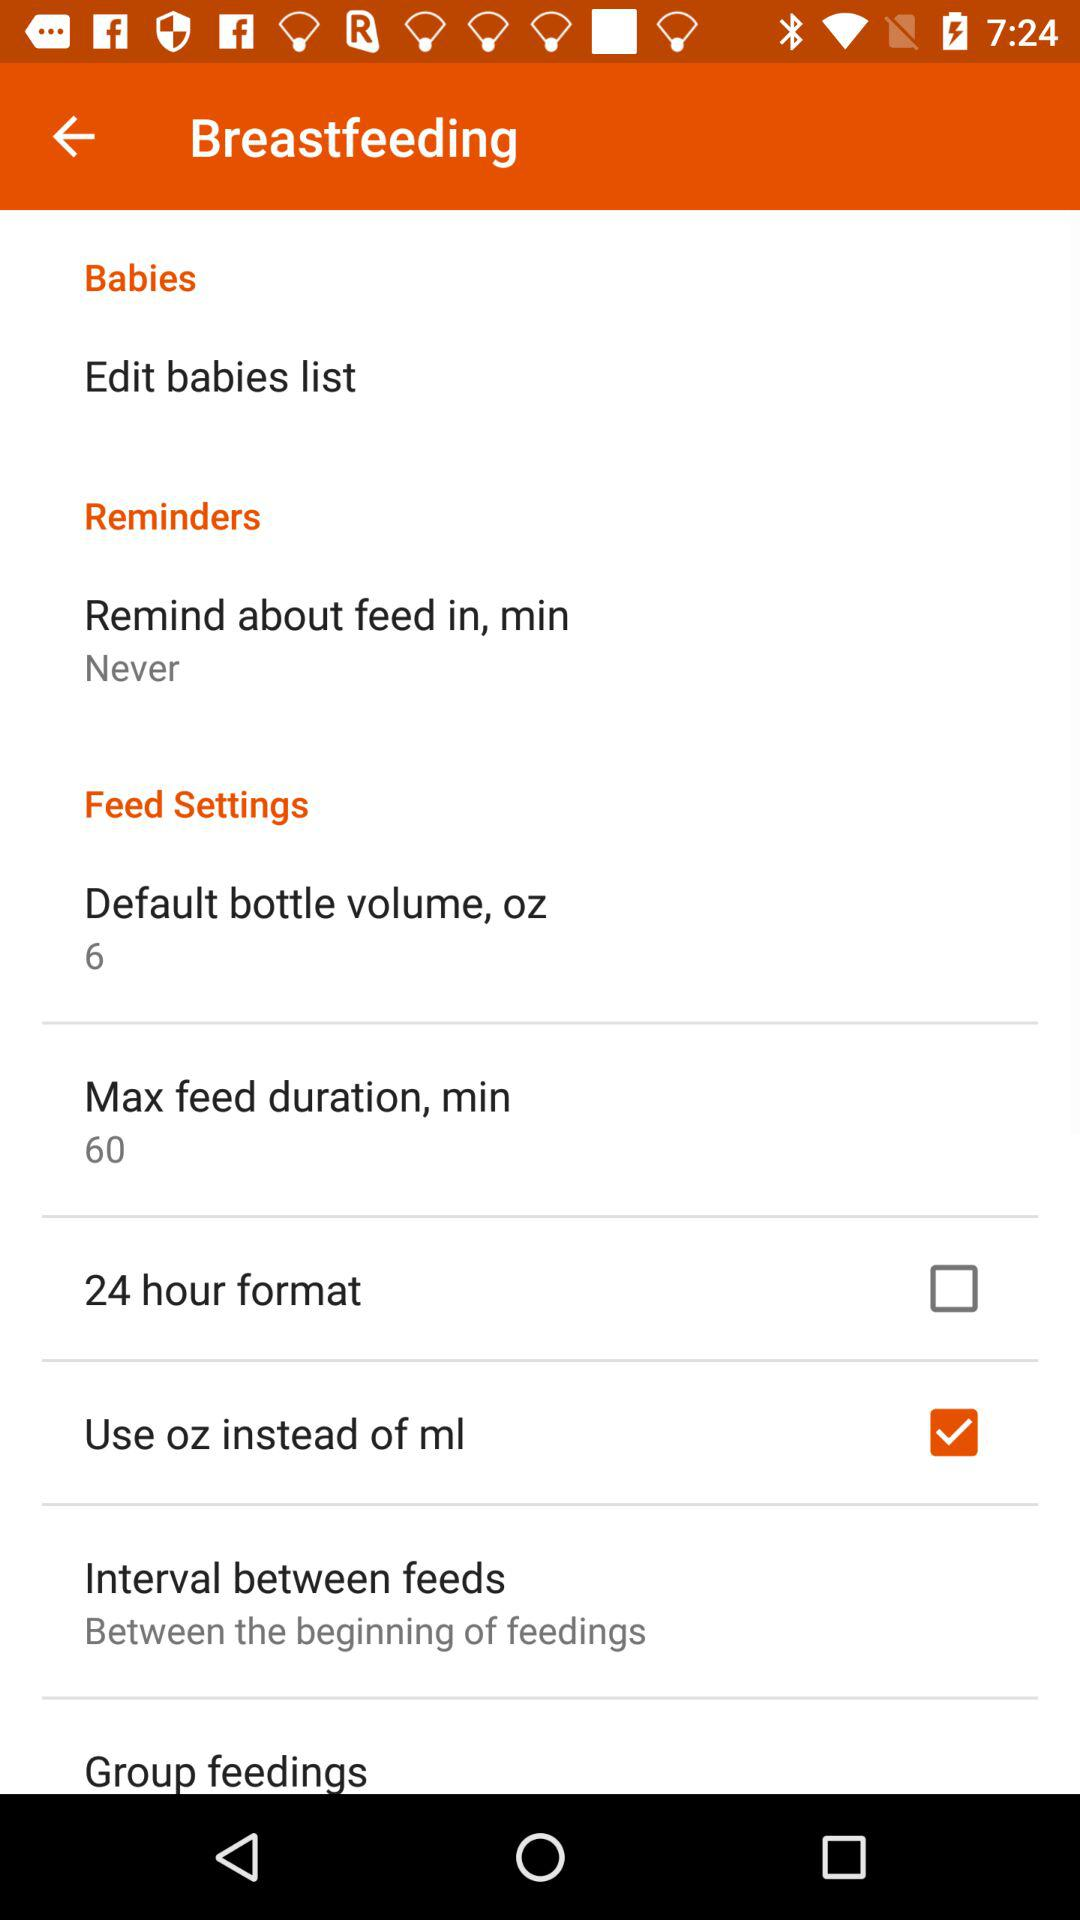What is the status of "24 hour format"? The status of "24 hour format" is "off". 